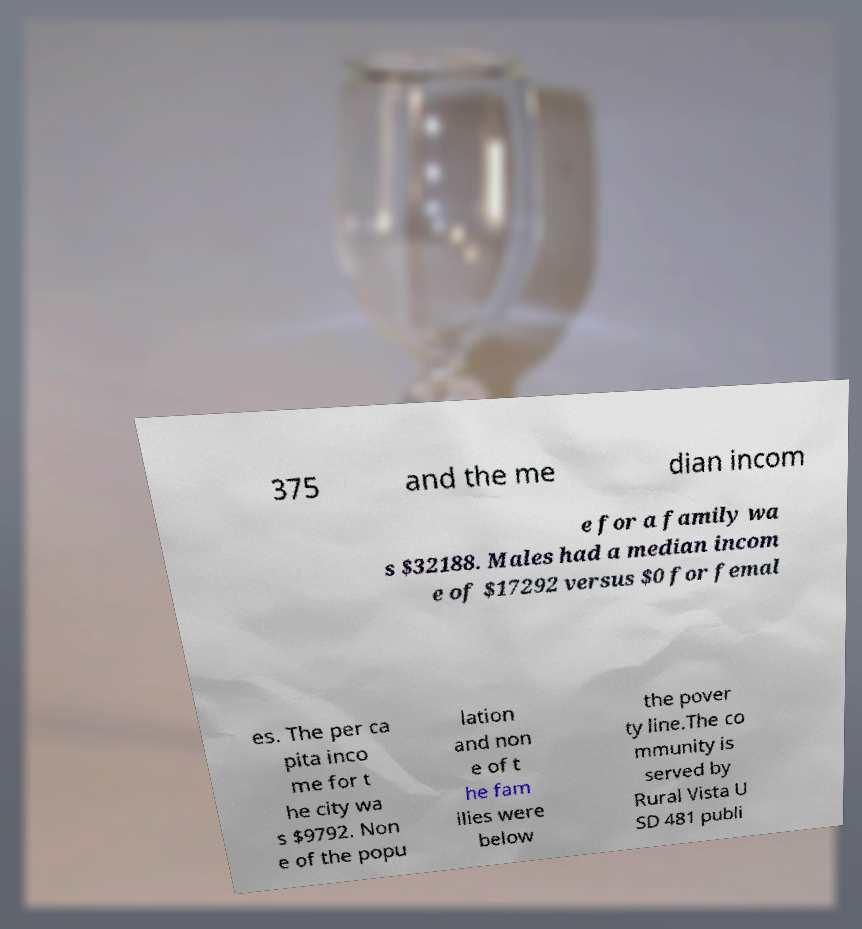There's text embedded in this image that I need extracted. Can you transcribe it verbatim? 375 and the me dian incom e for a family wa s $32188. Males had a median incom e of $17292 versus $0 for femal es. The per ca pita inco me for t he city wa s $9792. Non e of the popu lation and non e of t he fam ilies were below the pover ty line.The co mmunity is served by Rural Vista U SD 481 publi 